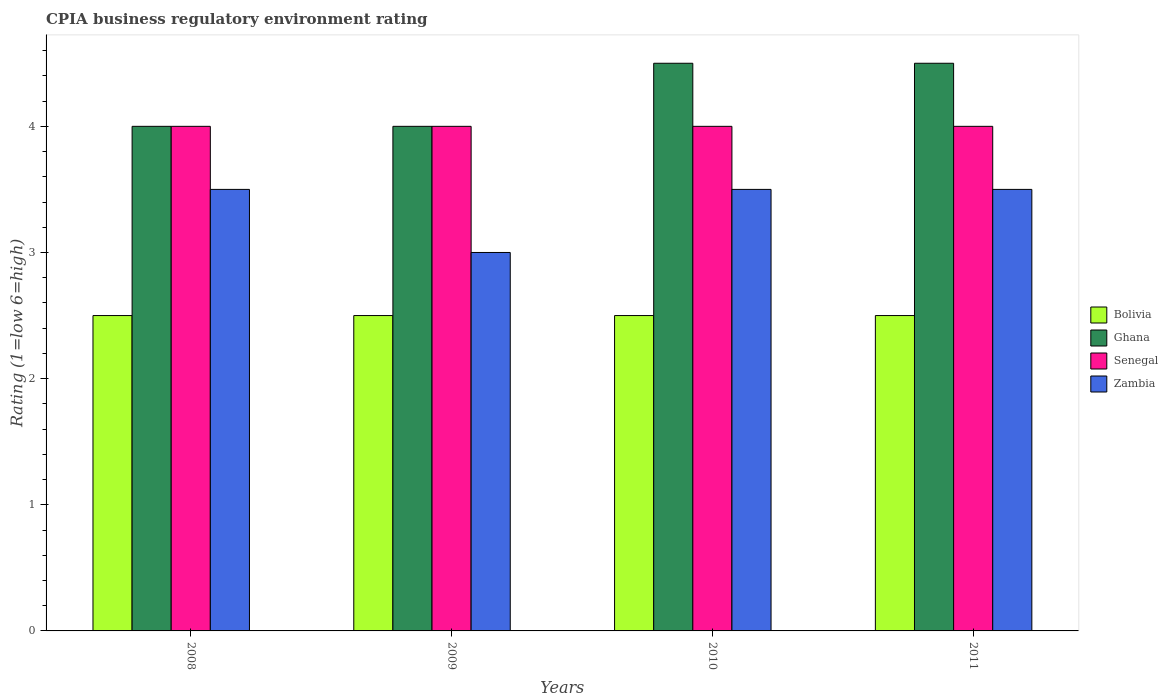How many groups of bars are there?
Your answer should be very brief. 4. Are the number of bars per tick equal to the number of legend labels?
Give a very brief answer. Yes. How many bars are there on the 1st tick from the left?
Provide a short and direct response. 4. What is the CPIA rating in Ghana in 2009?
Make the answer very short. 4. What is the total CPIA rating in Ghana in the graph?
Your answer should be very brief. 17. What is the difference between the CPIA rating in Ghana in 2008 and the CPIA rating in Senegal in 2009?
Keep it short and to the point. 0. What is the average CPIA rating in Ghana per year?
Offer a terse response. 4.25. In the year 2008, what is the difference between the CPIA rating in Zambia and CPIA rating in Senegal?
Provide a succinct answer. -0.5. In how many years, is the CPIA rating in Ghana greater than 4?
Keep it short and to the point. 2. What is the ratio of the CPIA rating in Bolivia in 2010 to that in 2011?
Provide a succinct answer. 1. What is the difference between the highest and the second highest CPIA rating in Zambia?
Provide a short and direct response. 0. In how many years, is the CPIA rating in Bolivia greater than the average CPIA rating in Bolivia taken over all years?
Your response must be concise. 0. Is it the case that in every year, the sum of the CPIA rating in Ghana and CPIA rating in Zambia is greater than the sum of CPIA rating in Bolivia and CPIA rating in Senegal?
Provide a succinct answer. No. What does the 1st bar from the left in 2009 represents?
Your answer should be compact. Bolivia. What does the 3rd bar from the right in 2010 represents?
Make the answer very short. Ghana. Are all the bars in the graph horizontal?
Provide a short and direct response. No. Are the values on the major ticks of Y-axis written in scientific E-notation?
Keep it short and to the point. No. Does the graph contain any zero values?
Provide a succinct answer. No. Where does the legend appear in the graph?
Keep it short and to the point. Center right. How many legend labels are there?
Your response must be concise. 4. How are the legend labels stacked?
Offer a terse response. Vertical. What is the title of the graph?
Your answer should be compact. CPIA business regulatory environment rating. Does "Romania" appear as one of the legend labels in the graph?
Ensure brevity in your answer.  No. What is the label or title of the X-axis?
Ensure brevity in your answer.  Years. What is the Rating (1=low 6=high) in Bolivia in 2008?
Offer a very short reply. 2.5. What is the Rating (1=low 6=high) of Senegal in 2008?
Ensure brevity in your answer.  4. What is the Rating (1=low 6=high) in Senegal in 2010?
Provide a succinct answer. 4. What is the Rating (1=low 6=high) in Zambia in 2010?
Provide a succinct answer. 3.5. What is the Rating (1=low 6=high) in Zambia in 2011?
Give a very brief answer. 3.5. Across all years, what is the maximum Rating (1=low 6=high) of Senegal?
Make the answer very short. 4. Across all years, what is the maximum Rating (1=low 6=high) in Zambia?
Offer a terse response. 3.5. Across all years, what is the minimum Rating (1=low 6=high) of Senegal?
Offer a terse response. 4. What is the total Rating (1=low 6=high) in Ghana in the graph?
Keep it short and to the point. 17. What is the difference between the Rating (1=low 6=high) in Bolivia in 2008 and that in 2009?
Give a very brief answer. 0. What is the difference between the Rating (1=low 6=high) of Senegal in 2008 and that in 2009?
Offer a terse response. 0. What is the difference between the Rating (1=low 6=high) in Ghana in 2008 and that in 2010?
Your answer should be compact. -0.5. What is the difference between the Rating (1=low 6=high) in Zambia in 2008 and that in 2010?
Offer a terse response. 0. What is the difference between the Rating (1=low 6=high) in Ghana in 2008 and that in 2011?
Offer a very short reply. -0.5. What is the difference between the Rating (1=low 6=high) of Bolivia in 2009 and that in 2010?
Ensure brevity in your answer.  0. What is the difference between the Rating (1=low 6=high) in Senegal in 2009 and that in 2010?
Ensure brevity in your answer.  0. What is the difference between the Rating (1=low 6=high) of Senegal in 2009 and that in 2011?
Ensure brevity in your answer.  0. What is the difference between the Rating (1=low 6=high) in Zambia in 2009 and that in 2011?
Keep it short and to the point. -0.5. What is the difference between the Rating (1=low 6=high) of Senegal in 2010 and that in 2011?
Ensure brevity in your answer.  0. What is the difference between the Rating (1=low 6=high) in Bolivia in 2008 and the Rating (1=low 6=high) in Ghana in 2009?
Offer a very short reply. -1.5. What is the difference between the Rating (1=low 6=high) of Ghana in 2008 and the Rating (1=low 6=high) of Zambia in 2009?
Offer a very short reply. 1. What is the difference between the Rating (1=low 6=high) in Bolivia in 2008 and the Rating (1=low 6=high) in Senegal in 2010?
Ensure brevity in your answer.  -1.5. What is the difference between the Rating (1=low 6=high) in Senegal in 2008 and the Rating (1=low 6=high) in Zambia in 2010?
Your answer should be compact. 0.5. What is the difference between the Rating (1=low 6=high) in Bolivia in 2008 and the Rating (1=low 6=high) in Senegal in 2011?
Offer a terse response. -1.5. What is the difference between the Rating (1=low 6=high) of Ghana in 2009 and the Rating (1=low 6=high) of Zambia in 2010?
Provide a succinct answer. 0.5. What is the difference between the Rating (1=low 6=high) of Senegal in 2009 and the Rating (1=low 6=high) of Zambia in 2010?
Offer a very short reply. 0.5. What is the difference between the Rating (1=low 6=high) of Bolivia in 2009 and the Rating (1=low 6=high) of Ghana in 2011?
Keep it short and to the point. -2. What is the difference between the Rating (1=low 6=high) in Senegal in 2009 and the Rating (1=low 6=high) in Zambia in 2011?
Ensure brevity in your answer.  0.5. What is the difference between the Rating (1=low 6=high) in Bolivia in 2010 and the Rating (1=low 6=high) in Senegal in 2011?
Your response must be concise. -1.5. What is the difference between the Rating (1=low 6=high) of Bolivia in 2010 and the Rating (1=low 6=high) of Zambia in 2011?
Offer a very short reply. -1. What is the difference between the Rating (1=low 6=high) of Senegal in 2010 and the Rating (1=low 6=high) of Zambia in 2011?
Keep it short and to the point. 0.5. What is the average Rating (1=low 6=high) in Ghana per year?
Provide a succinct answer. 4.25. What is the average Rating (1=low 6=high) of Senegal per year?
Give a very brief answer. 4. What is the average Rating (1=low 6=high) in Zambia per year?
Your response must be concise. 3.38. In the year 2008, what is the difference between the Rating (1=low 6=high) of Bolivia and Rating (1=low 6=high) of Ghana?
Keep it short and to the point. -1.5. In the year 2008, what is the difference between the Rating (1=low 6=high) in Bolivia and Rating (1=low 6=high) in Zambia?
Ensure brevity in your answer.  -1. In the year 2008, what is the difference between the Rating (1=low 6=high) of Ghana and Rating (1=low 6=high) of Senegal?
Provide a short and direct response. 0. In the year 2008, what is the difference between the Rating (1=low 6=high) in Senegal and Rating (1=low 6=high) in Zambia?
Your response must be concise. 0.5. In the year 2009, what is the difference between the Rating (1=low 6=high) of Bolivia and Rating (1=low 6=high) of Ghana?
Provide a short and direct response. -1.5. In the year 2009, what is the difference between the Rating (1=low 6=high) in Bolivia and Rating (1=low 6=high) in Senegal?
Your answer should be very brief. -1.5. In the year 2010, what is the difference between the Rating (1=low 6=high) in Bolivia and Rating (1=low 6=high) in Senegal?
Offer a terse response. -1.5. In the year 2010, what is the difference between the Rating (1=low 6=high) in Senegal and Rating (1=low 6=high) in Zambia?
Provide a succinct answer. 0.5. In the year 2011, what is the difference between the Rating (1=low 6=high) of Bolivia and Rating (1=low 6=high) of Ghana?
Your answer should be compact. -2. In the year 2011, what is the difference between the Rating (1=low 6=high) in Ghana and Rating (1=low 6=high) in Senegal?
Make the answer very short. 0.5. In the year 2011, what is the difference between the Rating (1=low 6=high) in Ghana and Rating (1=low 6=high) in Zambia?
Offer a very short reply. 1. What is the ratio of the Rating (1=low 6=high) of Bolivia in 2008 to that in 2009?
Your answer should be very brief. 1. What is the ratio of the Rating (1=low 6=high) in Ghana in 2008 to that in 2009?
Provide a succinct answer. 1. What is the ratio of the Rating (1=low 6=high) of Ghana in 2008 to that in 2010?
Give a very brief answer. 0.89. What is the ratio of the Rating (1=low 6=high) in Senegal in 2008 to that in 2010?
Ensure brevity in your answer.  1. What is the ratio of the Rating (1=low 6=high) in Zambia in 2008 to that in 2010?
Make the answer very short. 1. What is the ratio of the Rating (1=low 6=high) in Senegal in 2008 to that in 2011?
Keep it short and to the point. 1. What is the ratio of the Rating (1=low 6=high) of Bolivia in 2009 to that in 2010?
Keep it short and to the point. 1. What is the ratio of the Rating (1=low 6=high) of Senegal in 2009 to that in 2010?
Make the answer very short. 1. What is the ratio of the Rating (1=low 6=high) in Ghana in 2009 to that in 2011?
Your answer should be very brief. 0.89. What is the ratio of the Rating (1=low 6=high) in Senegal in 2009 to that in 2011?
Ensure brevity in your answer.  1. What is the ratio of the Rating (1=low 6=high) in Zambia in 2009 to that in 2011?
Ensure brevity in your answer.  0.86. What is the ratio of the Rating (1=low 6=high) of Ghana in 2010 to that in 2011?
Keep it short and to the point. 1. What is the ratio of the Rating (1=low 6=high) in Senegal in 2010 to that in 2011?
Your response must be concise. 1. What is the ratio of the Rating (1=low 6=high) of Zambia in 2010 to that in 2011?
Make the answer very short. 1. What is the difference between the highest and the second highest Rating (1=low 6=high) of Senegal?
Offer a very short reply. 0. What is the difference between the highest and the lowest Rating (1=low 6=high) of Bolivia?
Provide a short and direct response. 0. What is the difference between the highest and the lowest Rating (1=low 6=high) in Zambia?
Provide a short and direct response. 0.5. 